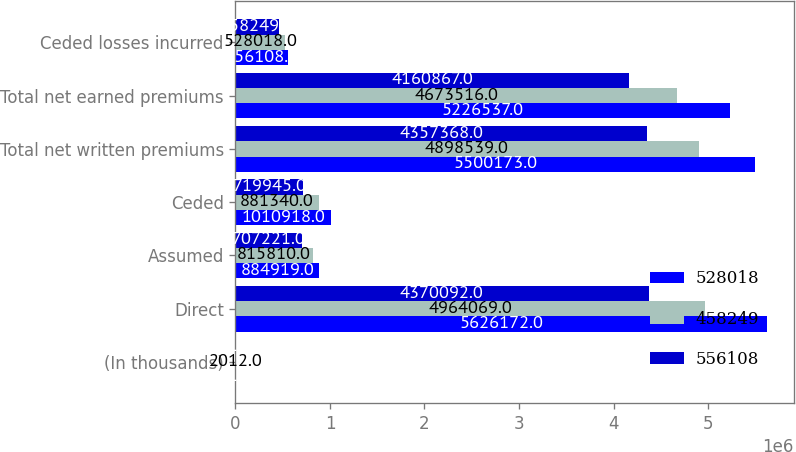Convert chart to OTSL. <chart><loc_0><loc_0><loc_500><loc_500><stacked_bar_chart><ecel><fcel>(In thousands)<fcel>Direct<fcel>Assumed<fcel>Ceded<fcel>Total net written premiums<fcel>Total net earned premiums<fcel>Ceded losses incurred<nl><fcel>528018<fcel>2013<fcel>5.62617e+06<fcel>884919<fcel>1.01092e+06<fcel>5.50017e+06<fcel>5.22654e+06<fcel>556108<nl><fcel>458249<fcel>2012<fcel>4.96407e+06<fcel>815810<fcel>881340<fcel>4.89854e+06<fcel>4.67352e+06<fcel>528018<nl><fcel>556108<fcel>2011<fcel>4.37009e+06<fcel>707221<fcel>719945<fcel>4.35737e+06<fcel>4.16087e+06<fcel>458249<nl></chart> 